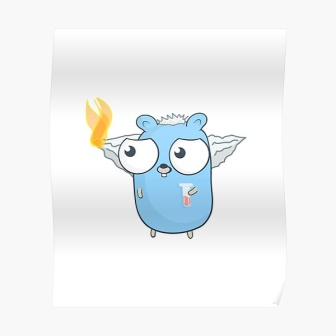Could you create a short, casual dialogue between this creature and another? Creature: *coughs* Hey, Featherwing, have you seen the healer around?
Featherwing: Oh no, Bluesy! You’re still not feeling better?
Creature: *holds up thermometer* It’s this darn flame. Keeps me feverish. Any clues where she might be?
Featherwing: Last I saw, she was gathering moon herbs by the stream. Let’s catch her before dusk!
Creature: Thanks, buddy. Let’s hurry; I can’t wait to put this fever to rest. 